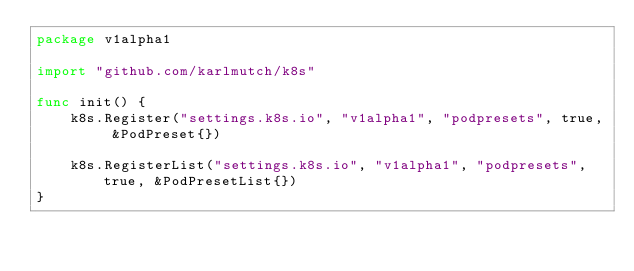Convert code to text. <code><loc_0><loc_0><loc_500><loc_500><_Go_>package v1alpha1

import "github.com/karlmutch/k8s"

func init() {
	k8s.Register("settings.k8s.io", "v1alpha1", "podpresets", true, &PodPreset{})

	k8s.RegisterList("settings.k8s.io", "v1alpha1", "podpresets", true, &PodPresetList{})
}
</code> 